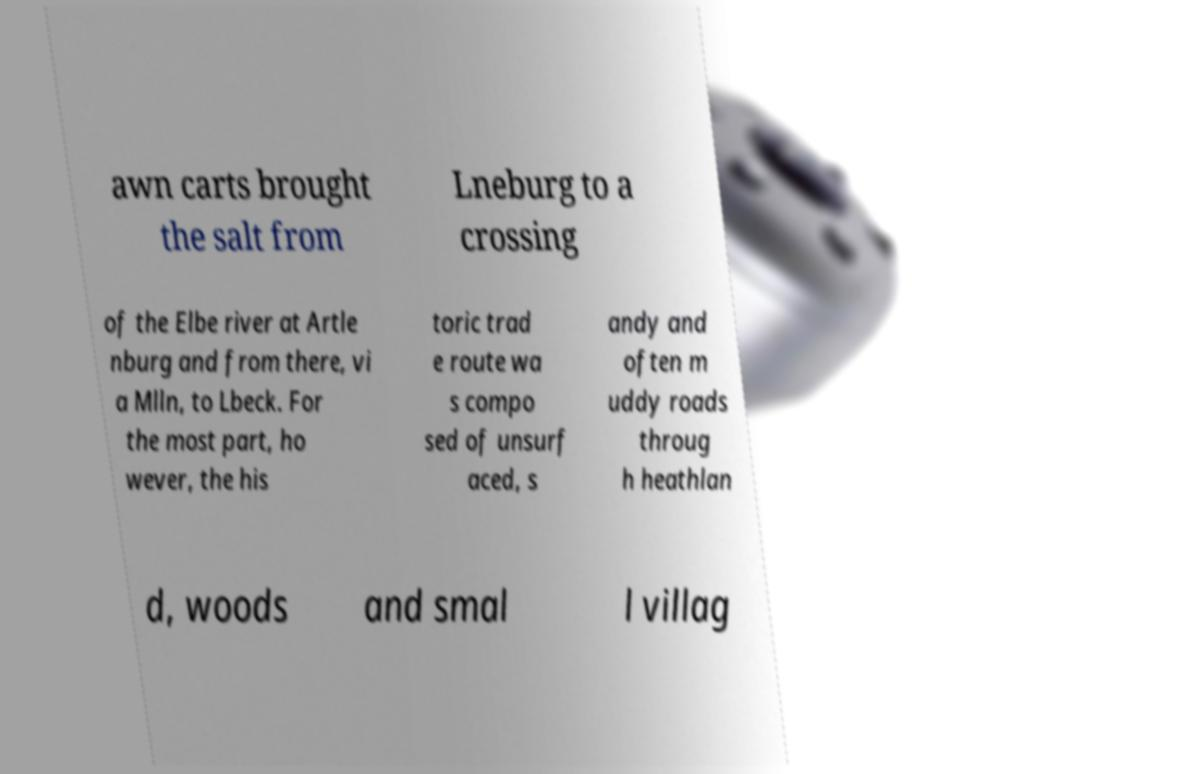I need the written content from this picture converted into text. Can you do that? awn carts brought the salt from Lneburg to a crossing of the Elbe river at Artle nburg and from there, vi a Mlln, to Lbeck. For the most part, ho wever, the his toric trad e route wa s compo sed of unsurf aced, s andy and often m uddy roads throug h heathlan d, woods and smal l villag 